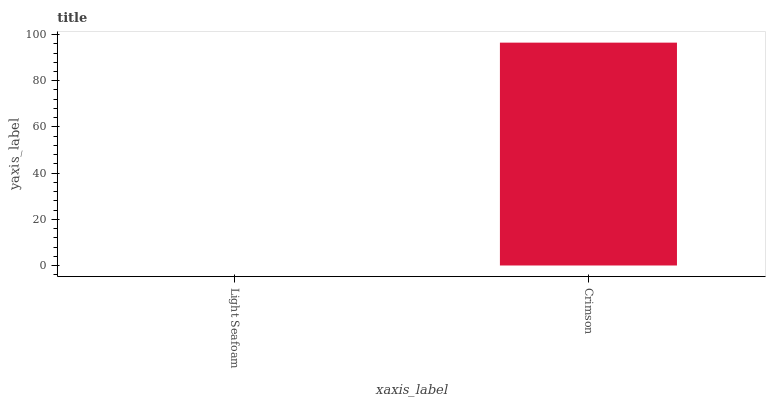Is Light Seafoam the minimum?
Answer yes or no. Yes. Is Crimson the maximum?
Answer yes or no. Yes. Is Crimson the minimum?
Answer yes or no. No. Is Crimson greater than Light Seafoam?
Answer yes or no. Yes. Is Light Seafoam less than Crimson?
Answer yes or no. Yes. Is Light Seafoam greater than Crimson?
Answer yes or no. No. Is Crimson less than Light Seafoam?
Answer yes or no. No. Is Crimson the high median?
Answer yes or no. Yes. Is Light Seafoam the low median?
Answer yes or no. Yes. Is Light Seafoam the high median?
Answer yes or no. No. Is Crimson the low median?
Answer yes or no. No. 